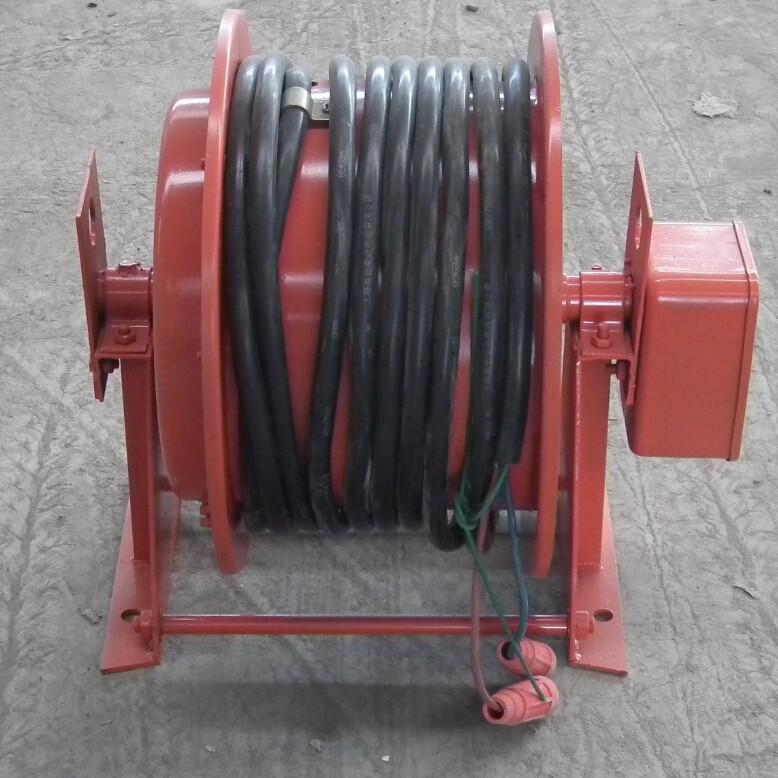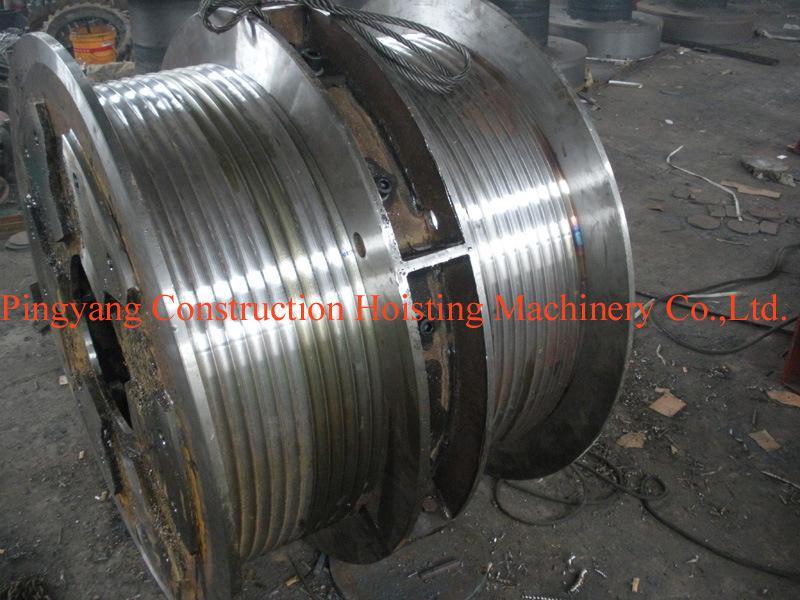The first image is the image on the left, the second image is the image on the right. Evaluate the accuracy of this statement regarding the images: "The left and right image contains the same amount of round metal barrels.". Is it true? Answer yes or no. Yes. 